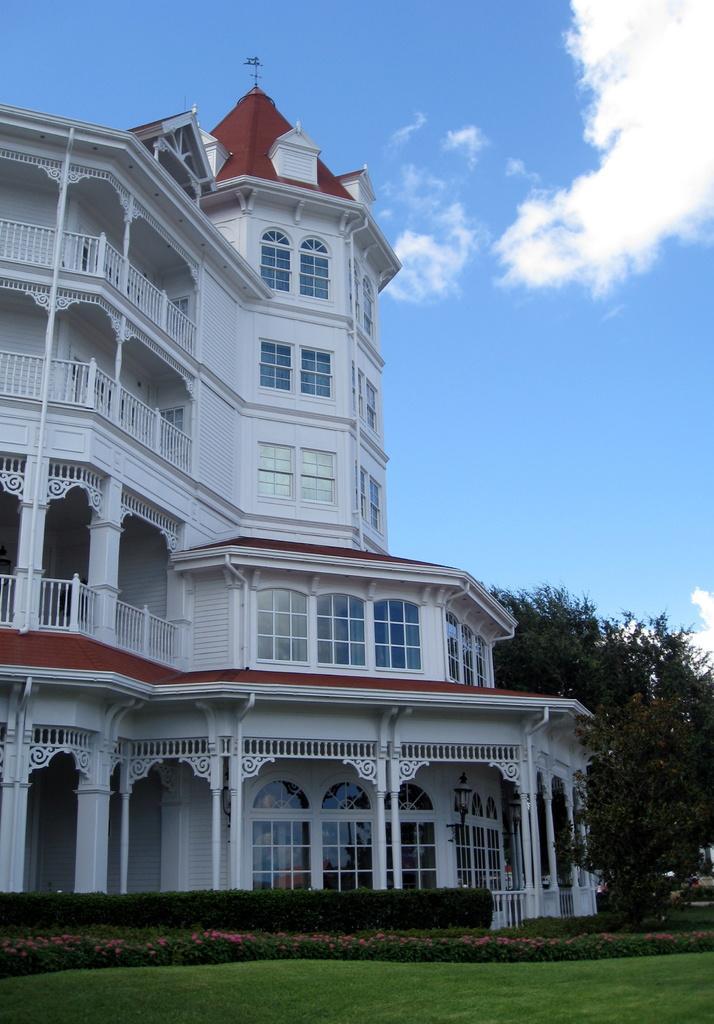How would you summarize this image in a sentence or two? This picture shows building and we see trees and plants and we see grass on the ground and a blue cloudy Sky. 